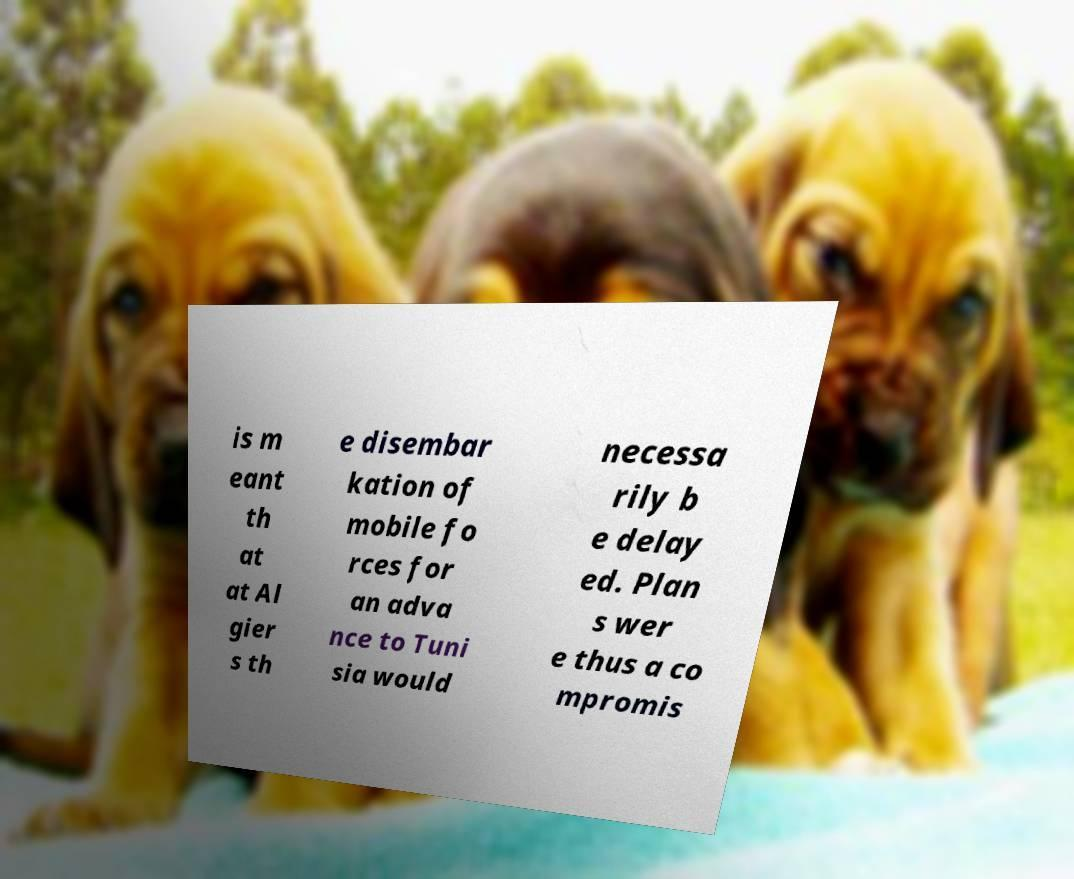For documentation purposes, I need the text within this image transcribed. Could you provide that? is m eant th at at Al gier s th e disembar kation of mobile fo rces for an adva nce to Tuni sia would necessa rily b e delay ed. Plan s wer e thus a co mpromis 